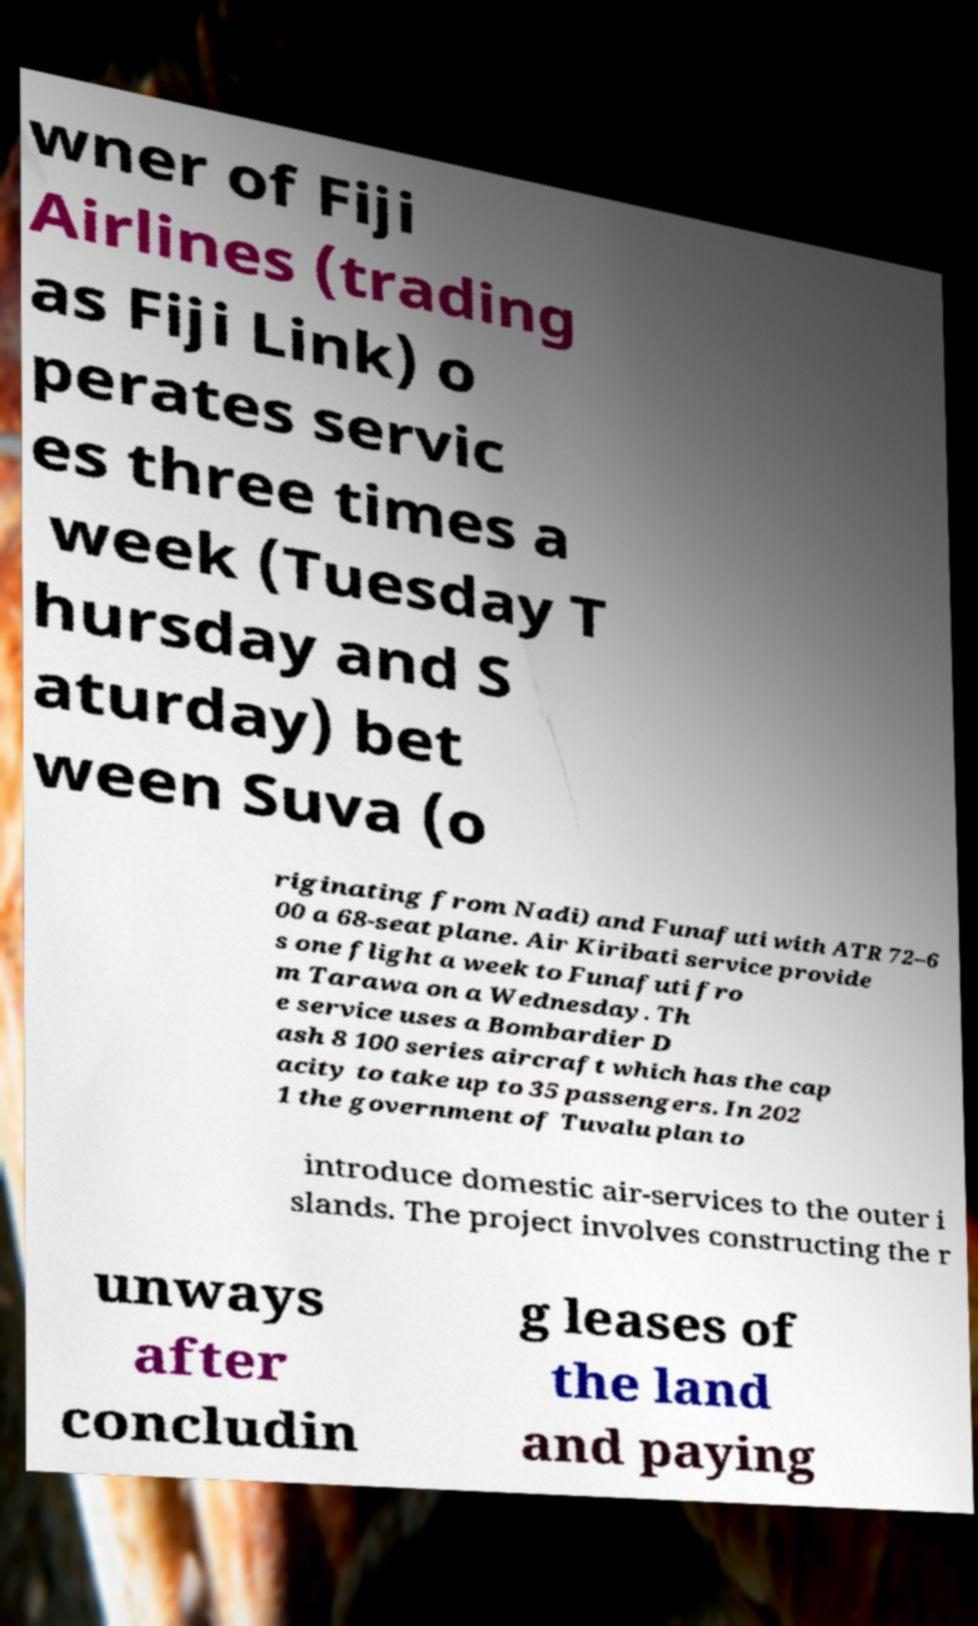Can you accurately transcribe the text from the provided image for me? wner of Fiji Airlines (trading as Fiji Link) o perates servic es three times a week (Tuesday T hursday and S aturday) bet ween Suva (o riginating from Nadi) and Funafuti with ATR 72–6 00 a 68-seat plane. Air Kiribati service provide s one flight a week to Funafuti fro m Tarawa on a Wednesday. Th e service uses a Bombardier D ash 8 100 series aircraft which has the cap acity to take up to 35 passengers. In 202 1 the government of Tuvalu plan to introduce domestic air-services to the outer i slands. The project involves constructing the r unways after concludin g leases of the land and paying 